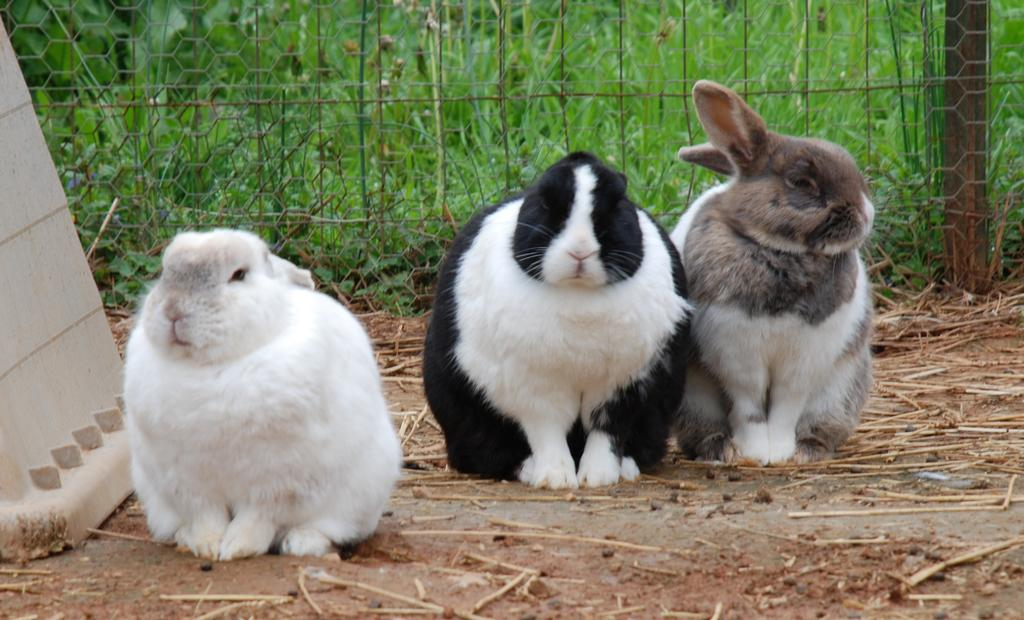How many rabbits are present in the image? There are three rabbits in the image. What is located behind the rabbits? There is fencing behind the rabbits. What type of vegetation can be seen behind the fencing? There is grass visible behind the fencing. What type of sail can be seen on the rabbits in the image? There is no sail present in the image; it features three rabbits and fencing. How many brothers are visible among the rabbits in the image? There is no indication of any brothers among the rabbits in the image, as they are not human and do not have familial relationships. 